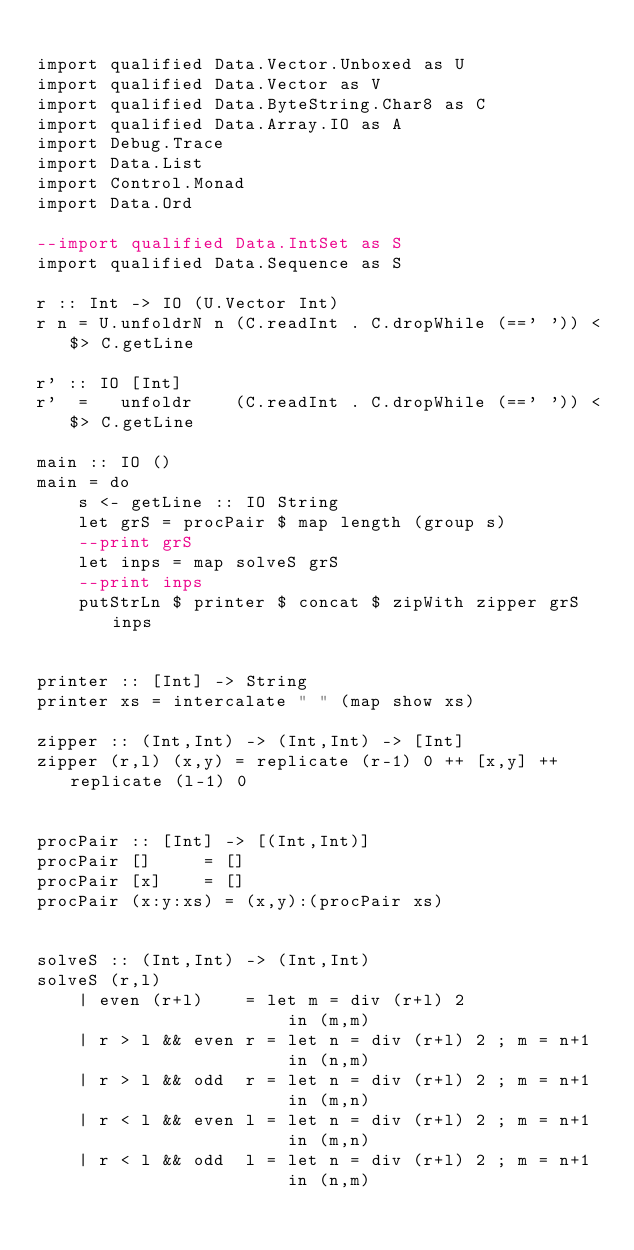Convert code to text. <code><loc_0><loc_0><loc_500><loc_500><_Haskell_>
import qualified Data.Vector.Unboxed as U
import qualified Data.Vector as V
import qualified Data.ByteString.Char8 as C
import qualified Data.Array.IO as A
import Debug.Trace
import Data.List
import Control.Monad
import Data.Ord

--import qualified Data.IntSet as S
import qualified Data.Sequence as S

r :: Int -> IO (U.Vector Int)
r n = U.unfoldrN n (C.readInt . C.dropWhile (==' ')) <$> C.getLine

r' :: IO [Int]
r'  =   unfoldr    (C.readInt . C.dropWhile (==' ')) <$> C.getLine

main :: IO ()
main = do
    s <- getLine :: IO String
    let grS = procPair $ map length (group s)
    --print grS
    let inps = map solveS grS
    --print inps
    putStrLn $ printer $ concat $ zipWith zipper grS inps


printer :: [Int] -> String
printer xs = intercalate " " (map show xs)

zipper :: (Int,Int) -> (Int,Int) -> [Int]
zipper (r,l) (x,y) = replicate (r-1) 0 ++ [x,y] ++ replicate (l-1) 0 


procPair :: [Int] -> [(Int,Int)]
procPair []     = []
procPair [x]    = []
procPair (x:y:xs) = (x,y):(procPair xs)


solveS :: (Int,Int) -> (Int,Int)
solveS (r,l)
    | even (r+l)    = let m = div (r+l) 2
                        in (m,m)
    | r > l && even r = let n = div (r+l) 2 ; m = n+1
                        in (n,m)
    | r > l && odd  r = let n = div (r+l) 2 ; m = n+1
                        in (m,n)
    | r < l && even l = let n = div (r+l) 2 ; m = n+1
                        in (m,n)
    | r < l && odd  l = let n = div (r+l) 2 ; m = n+1
                        in (n,m)

</code> 